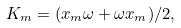Convert formula to latex. <formula><loc_0><loc_0><loc_500><loc_500>K _ { m } = ( x _ { m } \omega + \omega x _ { m } ) / 2 ,</formula> 